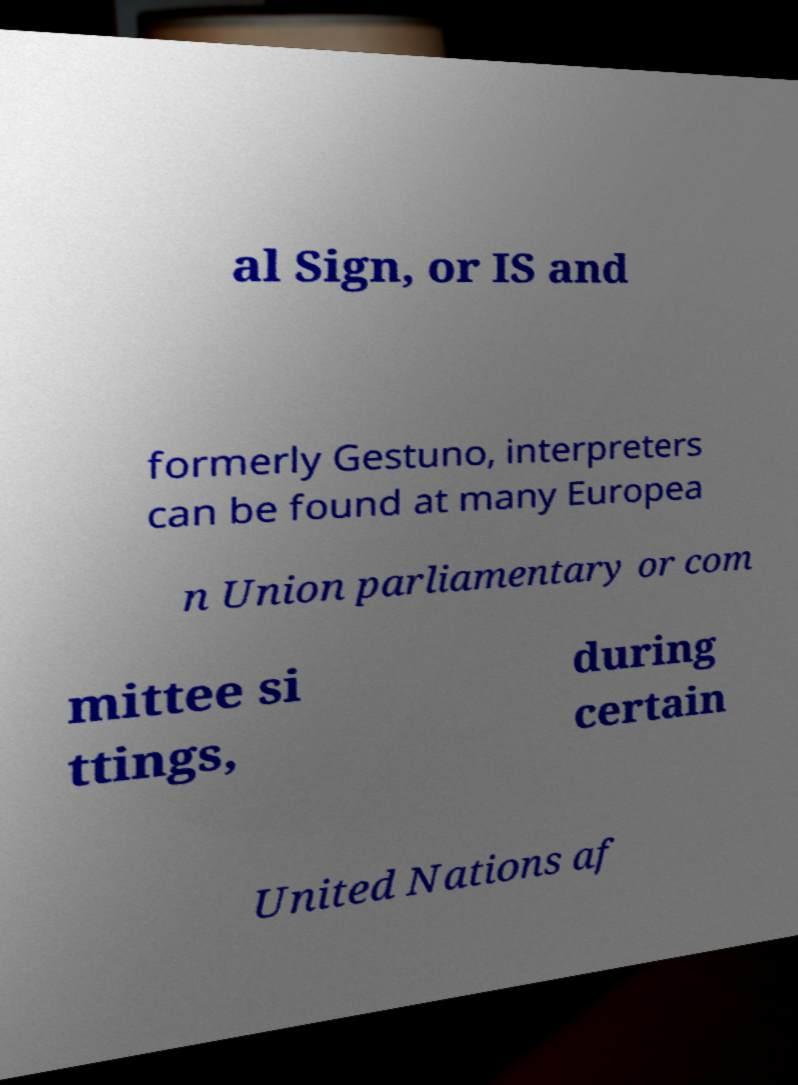Could you extract and type out the text from this image? al Sign, or IS and formerly Gestuno, interpreters can be found at many Europea n Union parliamentary or com mittee si ttings, during certain United Nations af 